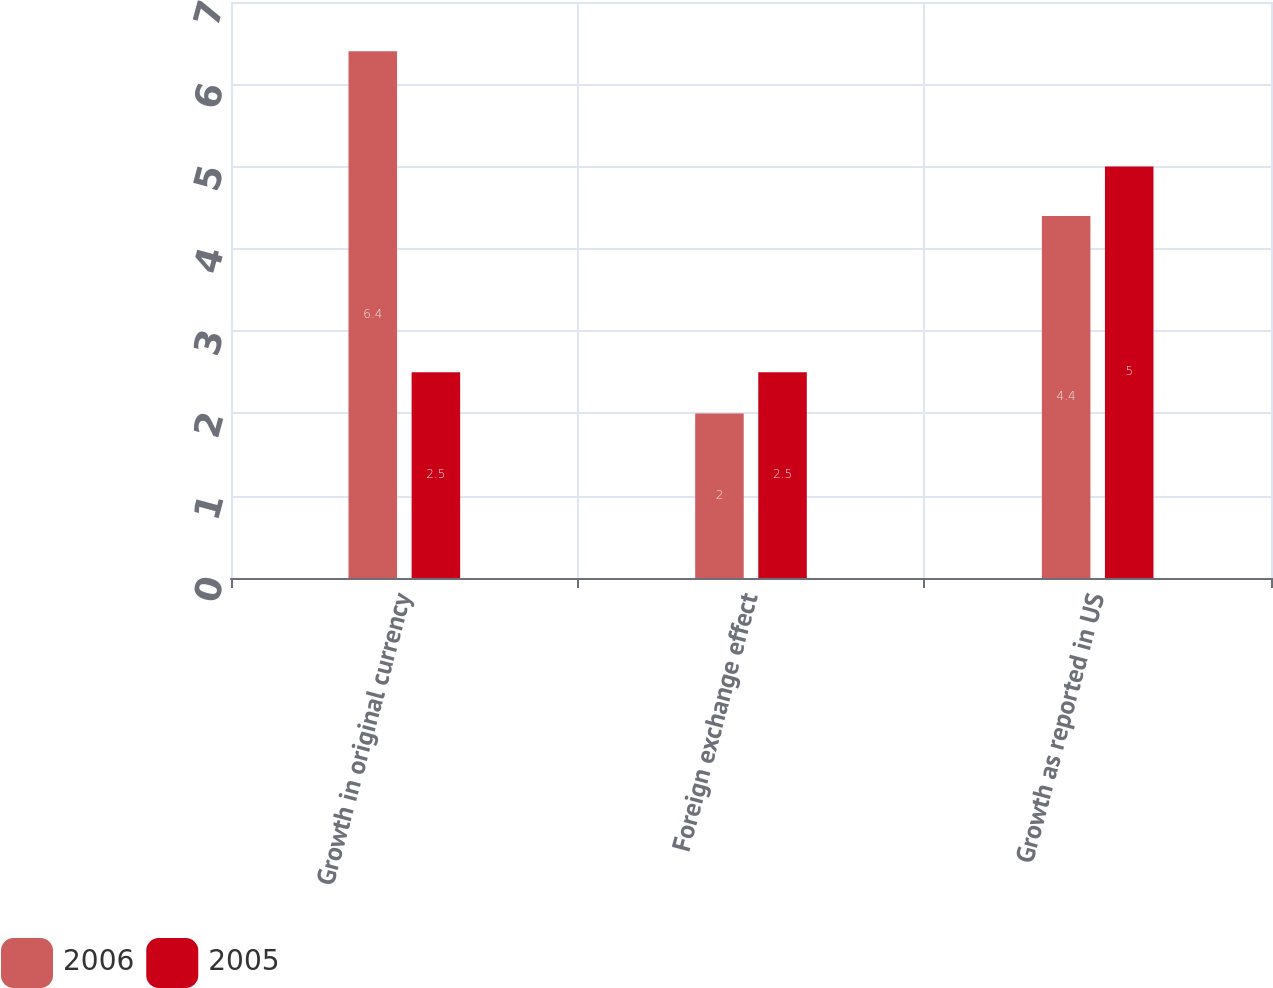<chart> <loc_0><loc_0><loc_500><loc_500><stacked_bar_chart><ecel><fcel>Growth in original currency<fcel>Foreign exchange effect<fcel>Growth as reported in US<nl><fcel>2006<fcel>6.4<fcel>2<fcel>4.4<nl><fcel>2005<fcel>2.5<fcel>2.5<fcel>5<nl></chart> 